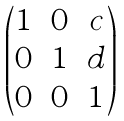Convert formula to latex. <formula><loc_0><loc_0><loc_500><loc_500>\begin{pmatrix} 1 & 0 & c \\ 0 & 1 & d \\ 0 & 0 & 1 \end{pmatrix}</formula> 